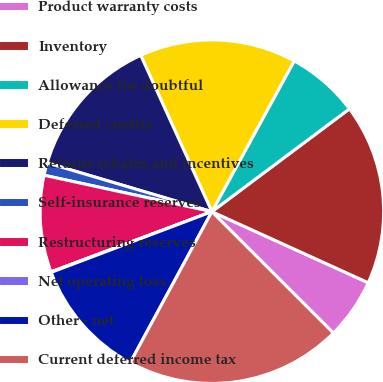<chart> <loc_0><loc_0><loc_500><loc_500><pie_chart><fcel>Product warranty costs<fcel>Inventory<fcel>Allowance for doubtful<fcel>Deferred credits<fcel>Returns rebates and incentives<fcel>Self-insurance reserves<fcel>Restructuring reserves<fcel>Net operating loss<fcel>Other - net<fcel>Current deferred income tax<nl><fcel>5.7%<fcel>17.01%<fcel>6.83%<fcel>14.75%<fcel>13.62%<fcel>1.18%<fcel>9.1%<fcel>0.05%<fcel>11.36%<fcel>20.4%<nl></chart> 